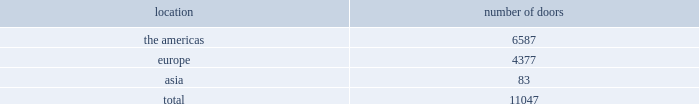Worldwide distribution channels the table presents the number of doors by geographic location , in which ralph lauren-branded products distributed by our wholesale segment were sold to consumers in our primary channels of distribution as of march 31 , 2012 : location number of .
In addition , american living and chaps-branded products distributed by our wholesale segment were sold domestically through approximately 1800 doors as of march 31 , 2012 .
We have three key wholesale customers that generate significant sales volume .
For fiscal 2012 , these customers in the aggregate accounted for approximately 40% ( 40 % ) of total wholesale revenues , with macy 2019s , inc .
Representing approximately 20% ( 20 % ) of total wholesale revenues .
Our product brands are sold primarily through our own sales forces .
Our wholesale segment maintains its primary showrooms in new york city .
In addition , we maintain regional showrooms in chicago , dallas , milan , paris , london , munich , madrid , stockholm and tokyo .
Shop-within-shops .
As a critical element of our distribution to department stores , we and our licensing partners utilize shop-within-shops to enhance brand recognition , to permit more complete merchandising of our lines by the department stores and to differentiate the presentation of products .
Shop-within- shop fixed assets primarily include items such as customized freestanding fixtures , wall cases and components , decorative items and flooring .
As of march 31 , 2012 , we had approximately 18000 shop-within-shops dedicated to our ralph lauren-branded wholesale products worldwide .
The size of our shop-within-shops ranges from approximately 300 to 7400 square feet .
We normally share in the cost of building-out these shop-within-shops with our wholesale customers .
Basic stock replenishment program .
Basic products such as knit shirts , chino pants , oxford cloth shirts , and selected accessories ( including footwear ) and home products can be ordered at any time through our basic stock replenishment programs .
We generally ship these products within two-to-five days of order receipt .
Our retail segment as of march 31 , 2012 , our retail segment consisted of 379 stores worldwide , totaling approximately 2.9 million gross square feet , 474 concessions- based shop-within-shops and six e-commerce websites .
The extension of our direct-to-consumer reach is a primary long-term strategic goal .
Ralph lauren retail stores our ralph lauren retail stores reinforce the luxury image and distinct sensibility of our brands and feature exclusive lines that are not sold in domestic department stores .
We opened 10 new ralph lauren stores , acquired 3 previously licensed stores , and closed 16 ralph lauren stores in fiscal 2012 .
Our retail stores are primarily situated in major upscale street locations and upscale regional malls , generally in large urban markets. .
What percentage of worldwide distribution channels doors as of march 31 , 2012 where in europe ? 
Computations: (4377 / 11047)
Answer: 0.39622. 